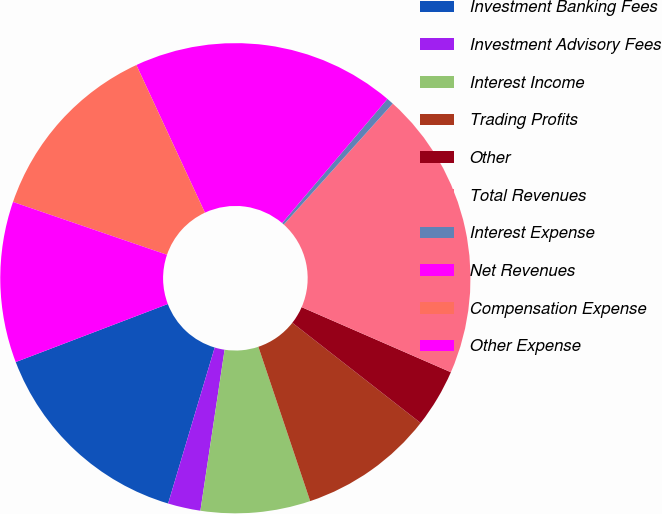Convert chart. <chart><loc_0><loc_0><loc_500><loc_500><pie_chart><fcel>Investment Banking Fees<fcel>Investment Advisory Fees<fcel>Interest Income<fcel>Trading Profits<fcel>Other<fcel>Total Revenues<fcel>Interest Expense<fcel>Net Revenues<fcel>Compensation Expense<fcel>Other Expense<nl><fcel>14.58%<fcel>2.24%<fcel>7.53%<fcel>9.29%<fcel>4.01%<fcel>19.87%<fcel>0.48%<fcel>18.11%<fcel>12.82%<fcel>11.06%<nl></chart> 